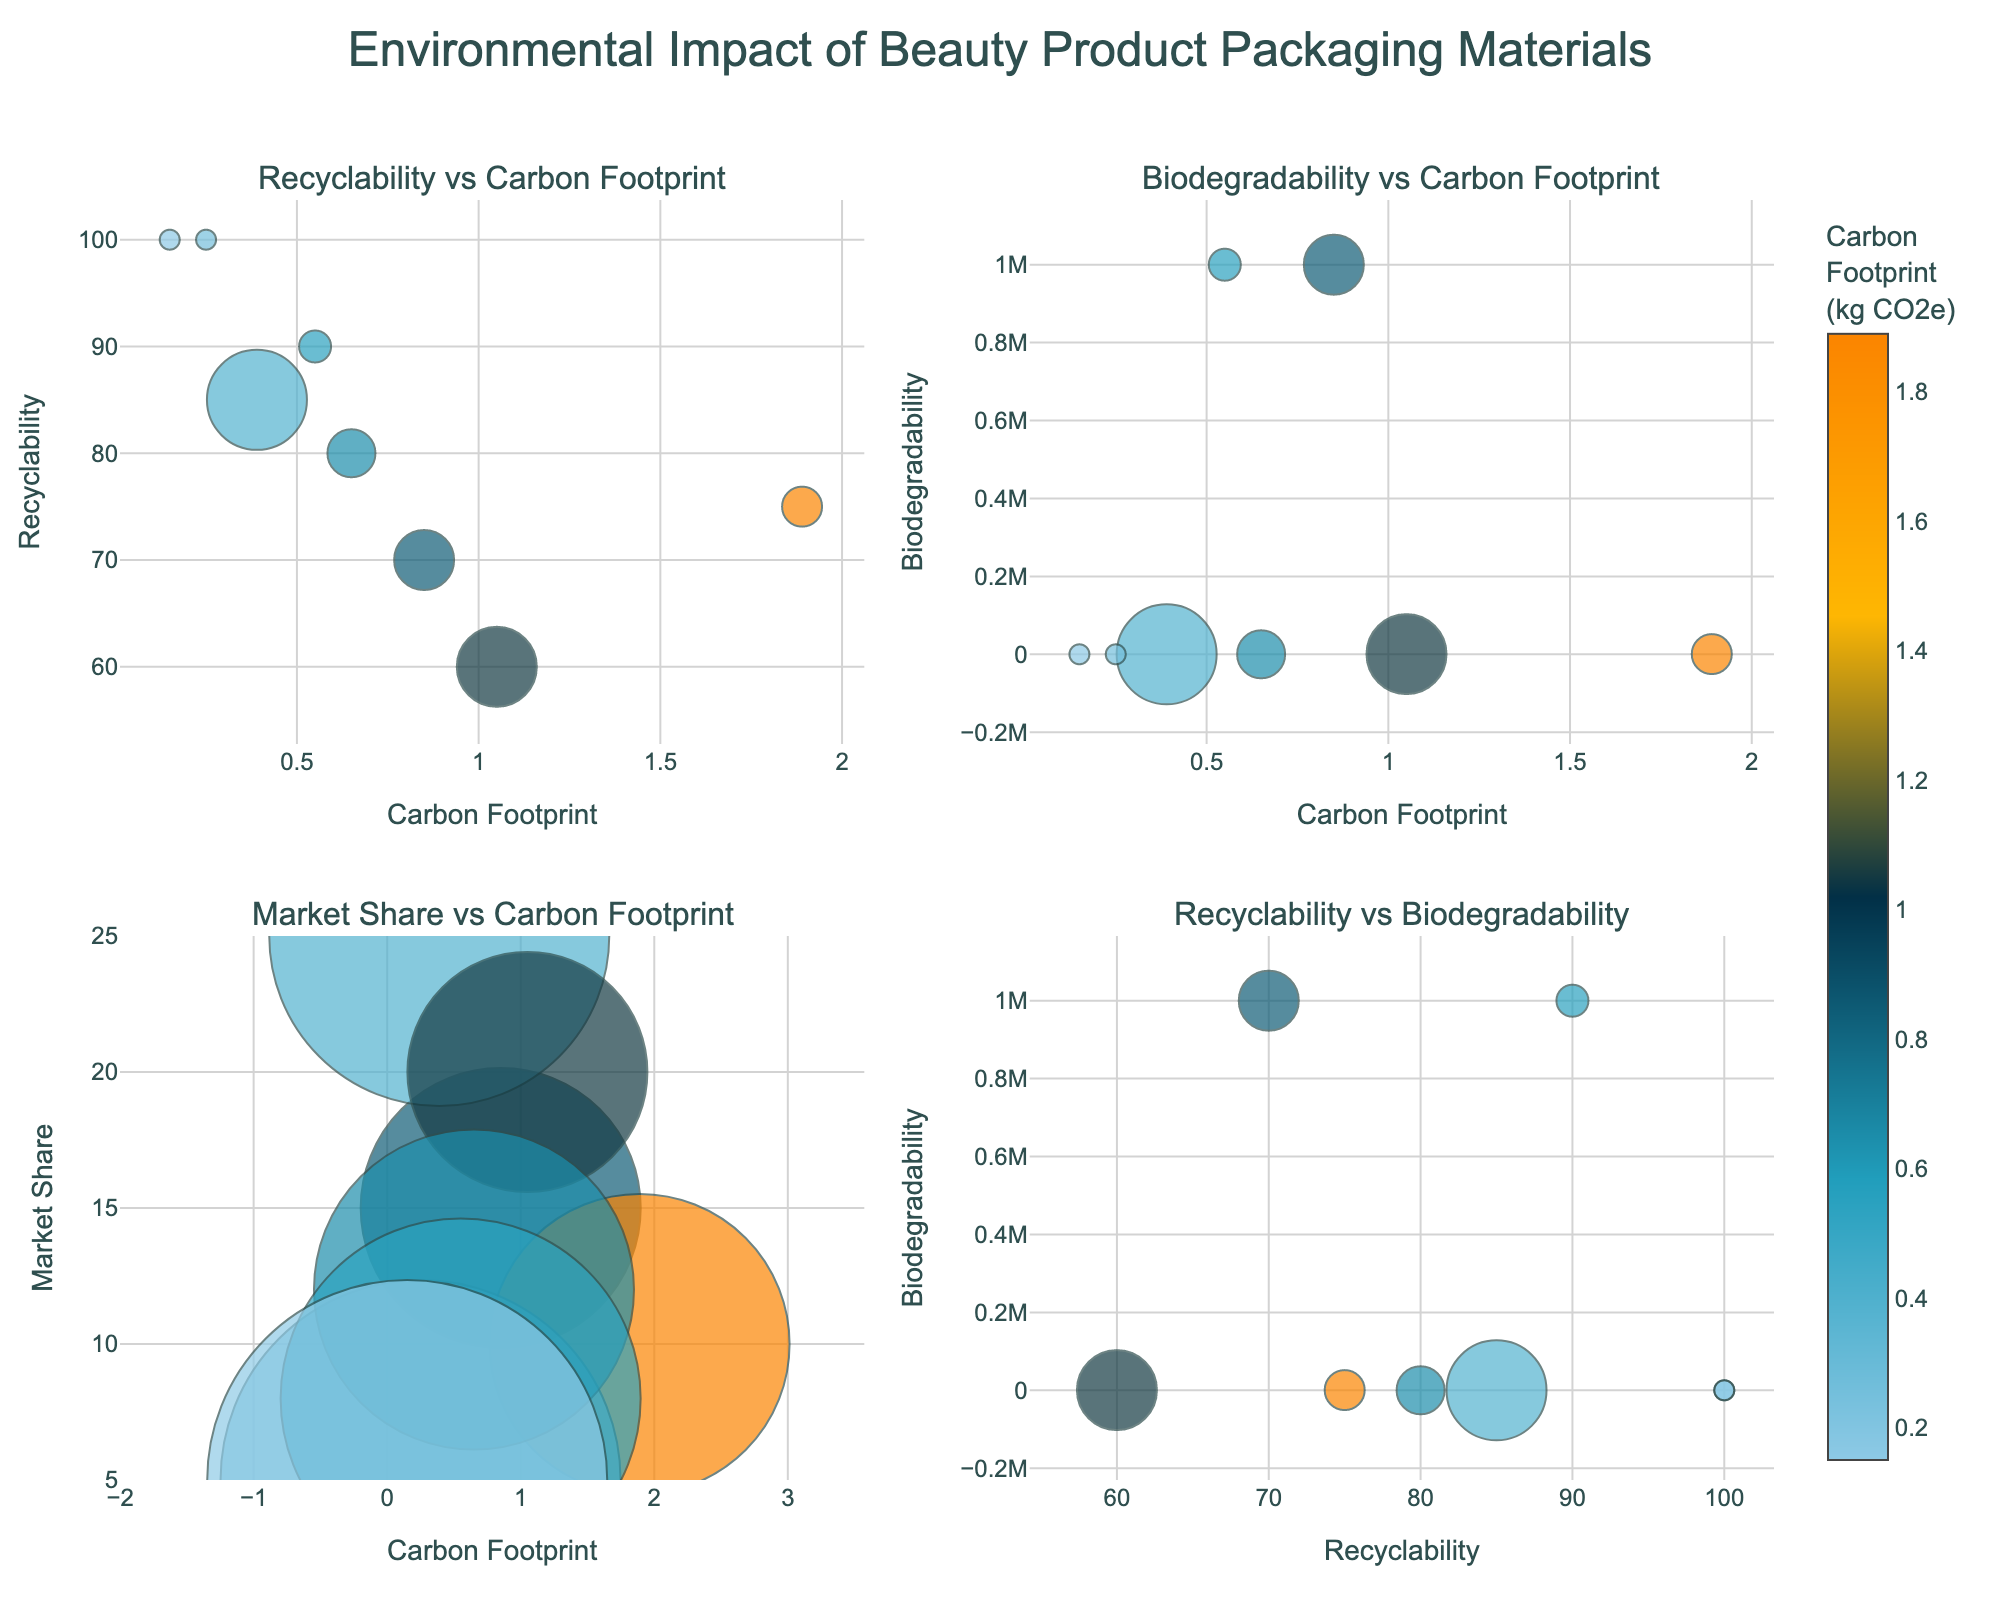What's the title of the figure? The title is prominently displayed at the top center of the figure.
Answer: Environmental Impact of Beauty Product Packaging Materials Which material has the highest recyclability percentage? Referring to the subplot titled "Recyclability vs Biodegradability" or "Recyclability vs Carbon Footprint," the material with the highest recyclability percentage can be identified quickly.
Answer: Natural Clay and Bamboo In the subplot "Recyclability vs Carbon Footprint," which material has the largest bubble? By looking at the size of the bubbles in the mentioned subplot, the largest one corresponds to the material with the highest market share.
Answer: Paper What is the relationship between carbon footprint and recyclability for aluminum compared to paper? By comparing the positions of aluminum and paper on both the x-axis (Carbon Footprint) and y-axis (Recyclability) in the "Recyclability vs Carbon Footprint" subplot, we can understand the differences. Aluminum has a higher carbon footprint and lower recyclability than paper.
Answer: Aluminum has a higher carbon footprint and lower recyclability than paper Which material has the shortest biodegradability period and what is its recyclability percentage? Referring to the subplot titled "Biodegradability vs Carbon Footprint" and "Recyclability vs Biodegradability," the shortest biodegradability is observed for Natural Clay, and its recyclability percentage is 100%.
Answer: Natural Clay; 100% Between bamboo and bioplastic, which has a lower carbon footprint, and by how much? By checking their carbon footprints in the subplot "Recyclability vs Carbon Footprint" or any subplot showing carbon footprints, we compare the values to find the difference. Bamboo has 0.25 kg CO2e and bioplastic has 0.65 kg CO2e, so bamboo has a lower carbon footprint by 0.4 kg CO2e.
Answer: Bamboo, 0.4 kg CO2e Which two materials have the same market share, and what is that percentage? Looking at the bubble sizes and the corresponding hover text in any subplot, we find that Natural Clay and Bamboo both occupy 5% of the market share.
Answer: Natural Clay and Bamboo; 5% What can you infer about the relationship between carbon footprint and biodegradability from the subplot "Biodegradability vs Carbon Footprint"? Observing the overall distribution of bubbles in this subplot, materials with shorter biodegradability periods tend to have a lower carbon footprint, while materials with longer biodegradability periods, like Glass and Refillable Glass, have a slightly lower carbon footprint compared to others due to their market shares.
Answer: Shorter biodegradability often correlates with lower carbon footprint Comparing glass and recycled plastic, which one has a higher carbon footprint and how does their recyclability percentage differ? In the subplot "Recyclability vs Carbon Footprint," Glass has a lower carbon footprint (0.85 kg CO2e) than Recycled Plastic (1.05 kg CO2e). Glass has a slightly higher recyclability percentage (70%) compared to Recycled Plastic (60%).
Answer: Recycled Plastic; Glass is 10% higher in recyclability 